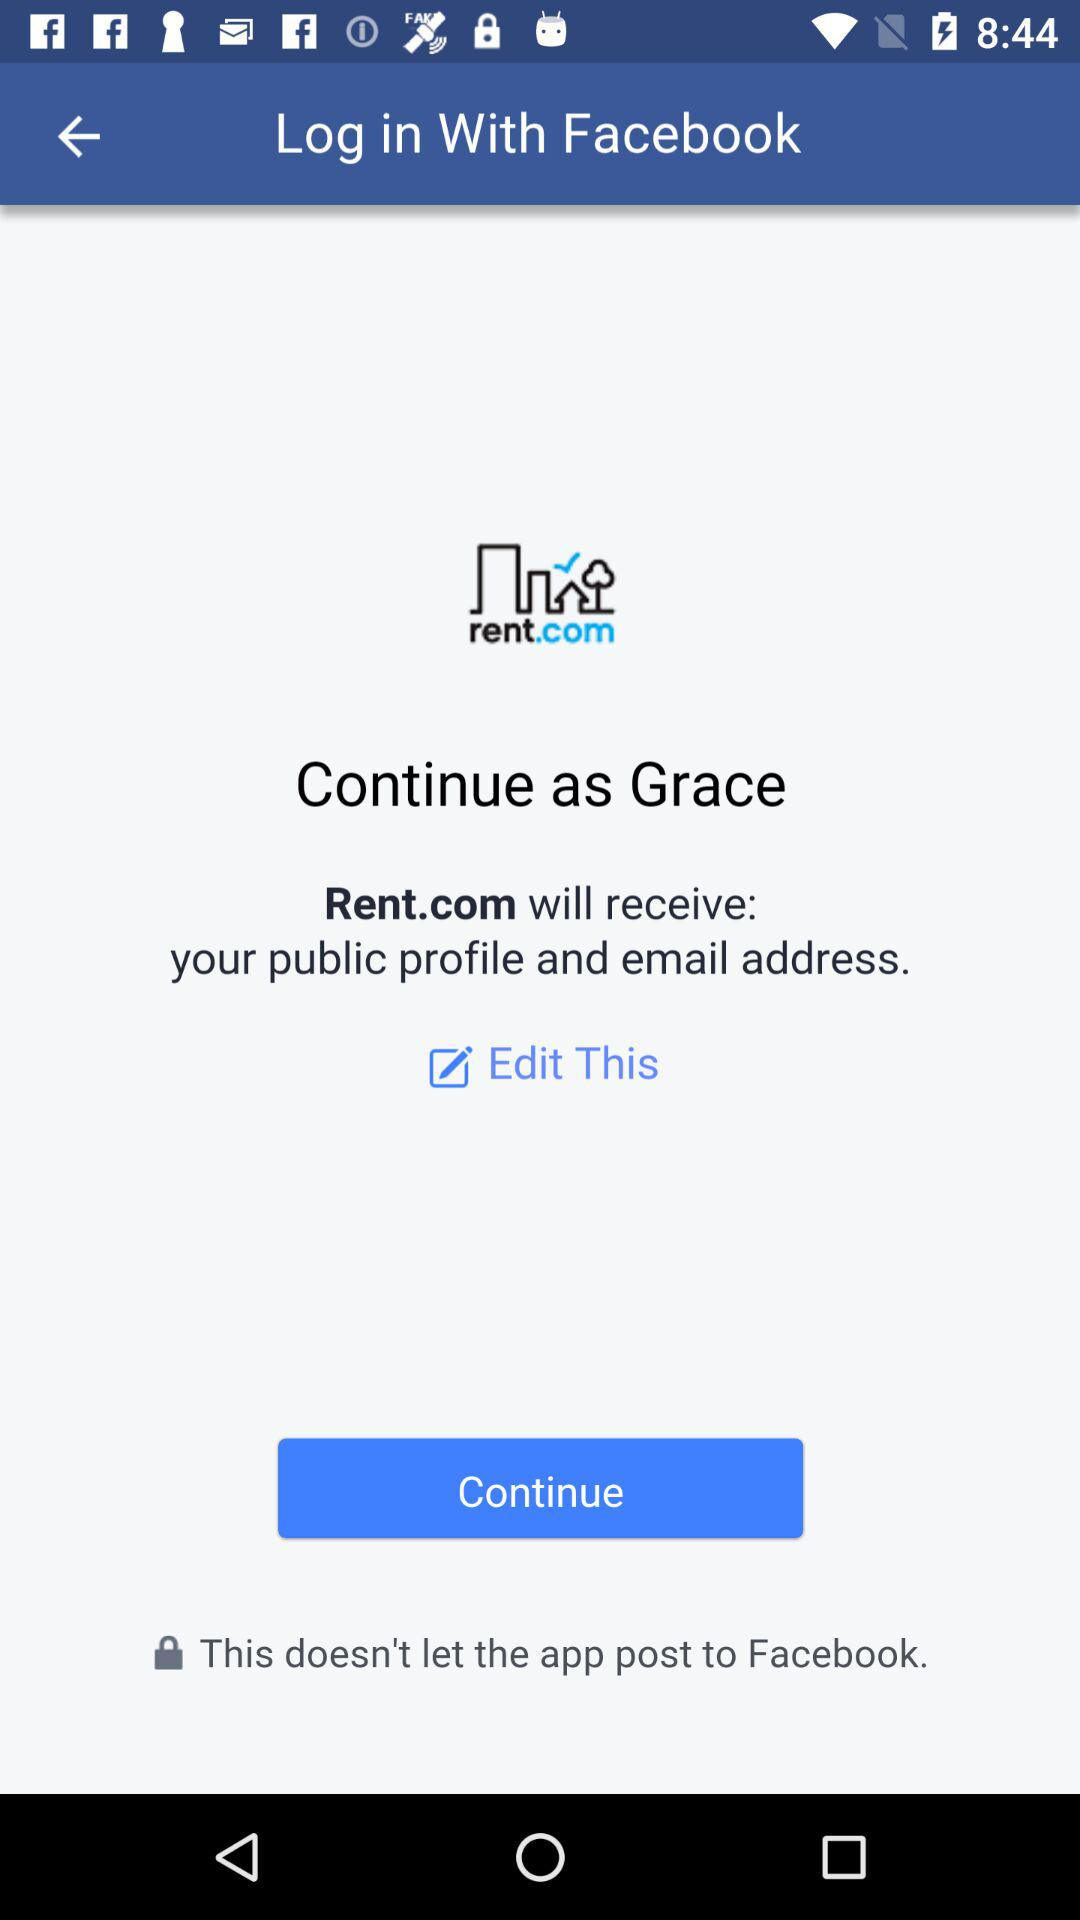Through what application is the person logging in? The person is logging in through "Facebook". 